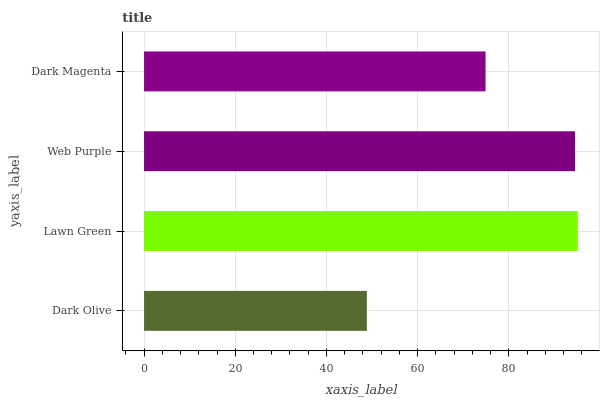Is Dark Olive the minimum?
Answer yes or no. Yes. Is Lawn Green the maximum?
Answer yes or no. Yes. Is Web Purple the minimum?
Answer yes or no. No. Is Web Purple the maximum?
Answer yes or no. No. Is Lawn Green greater than Web Purple?
Answer yes or no. Yes. Is Web Purple less than Lawn Green?
Answer yes or no. Yes. Is Web Purple greater than Lawn Green?
Answer yes or no. No. Is Lawn Green less than Web Purple?
Answer yes or no. No. Is Web Purple the high median?
Answer yes or no. Yes. Is Dark Magenta the low median?
Answer yes or no. Yes. Is Dark Magenta the high median?
Answer yes or no. No. Is Lawn Green the low median?
Answer yes or no. No. 